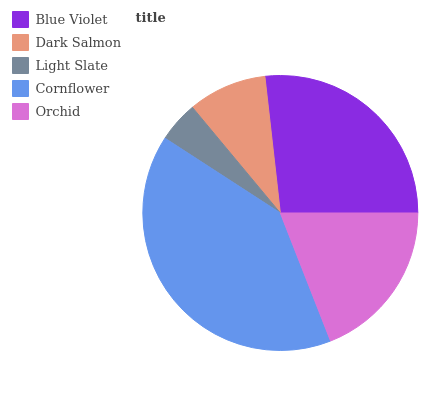Is Light Slate the minimum?
Answer yes or no. Yes. Is Cornflower the maximum?
Answer yes or no. Yes. Is Dark Salmon the minimum?
Answer yes or no. No. Is Dark Salmon the maximum?
Answer yes or no. No. Is Blue Violet greater than Dark Salmon?
Answer yes or no. Yes. Is Dark Salmon less than Blue Violet?
Answer yes or no. Yes. Is Dark Salmon greater than Blue Violet?
Answer yes or no. No. Is Blue Violet less than Dark Salmon?
Answer yes or no. No. Is Orchid the high median?
Answer yes or no. Yes. Is Orchid the low median?
Answer yes or no. Yes. Is Light Slate the high median?
Answer yes or no. No. Is Cornflower the low median?
Answer yes or no. No. 